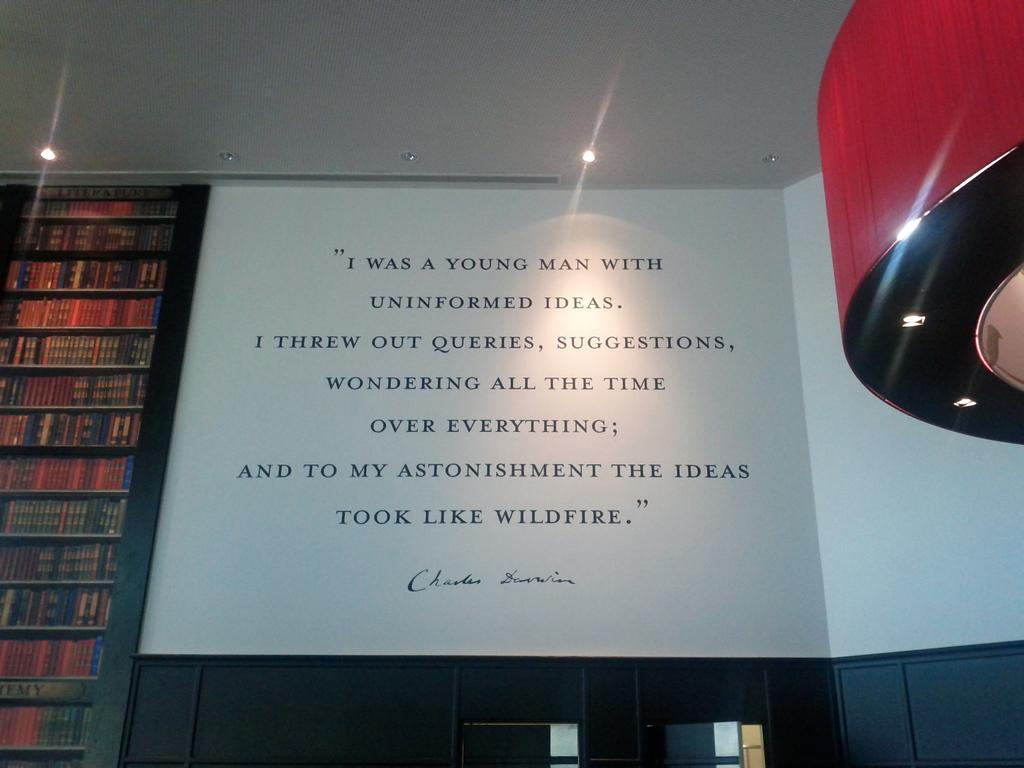<image>
Render a clear and concise summary of the photo. A quote is a book is shown by an author with the first name Charles. 